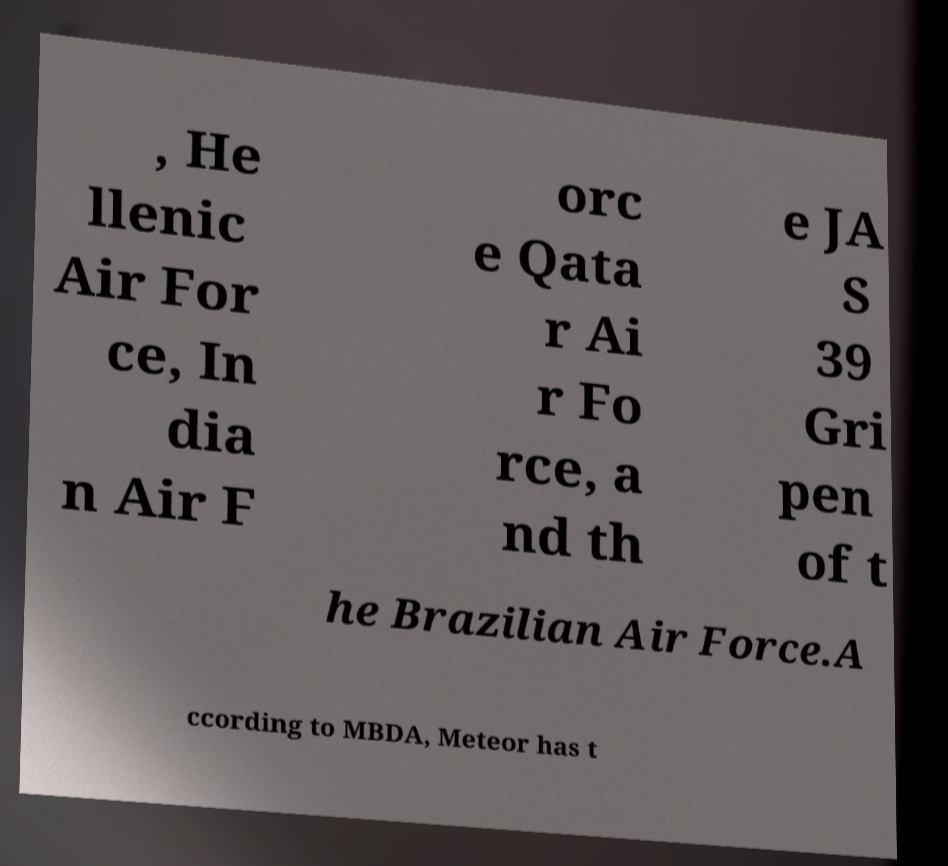Please identify and transcribe the text found in this image. , He llenic Air For ce, In dia n Air F orc e Qata r Ai r Fo rce, a nd th e JA S 39 Gri pen of t he Brazilian Air Force.A ccording to MBDA, Meteor has t 